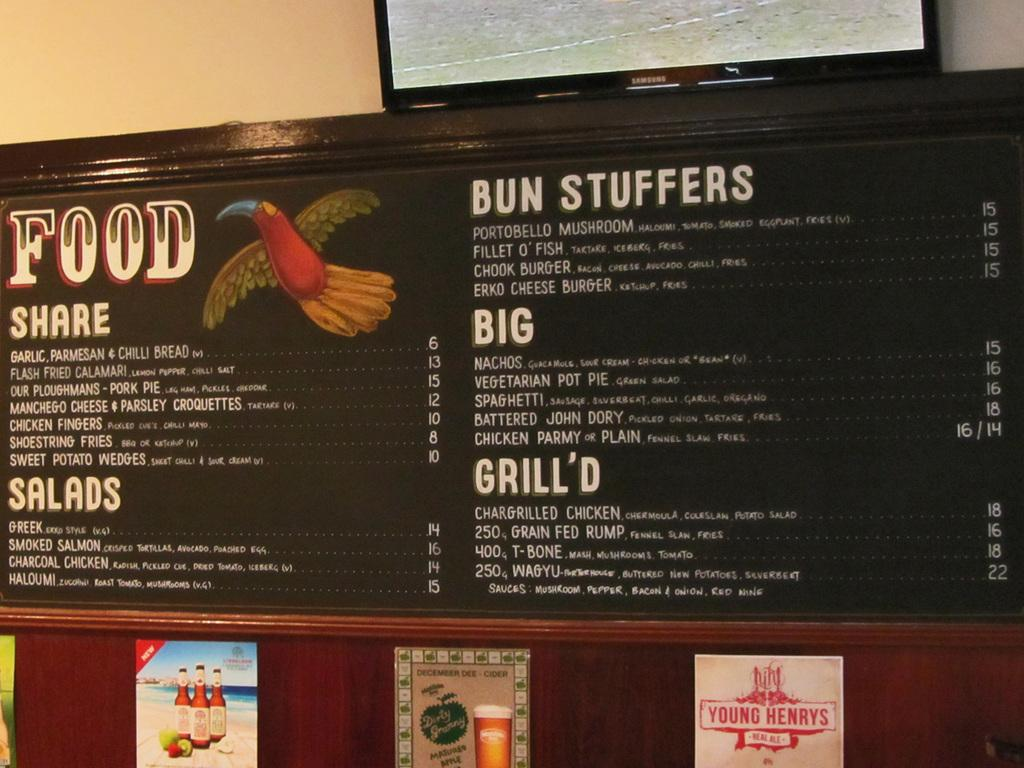<image>
Provide a brief description of the given image. A restaurant menu on the wall which offers Bun Stuffers as an option. 